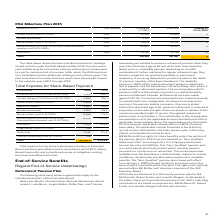According to Sap Ag's financial document, How was the Total expense for the share-based payment plans of Executive Board members determined? in accordance with IFRS 2 (Share- Based Payments) and consists exclusively of obligations arising from Executive Board activities.. The document states: "Board members was determined in accordance with IFRS 2 (Share- Based Payments) and consists exclusively of obligations arising from Executive Board ac..." Also, What is the total amount of expense for share-based payment in 2019? According to the financial document, 44,446.5 (in thousands). The relevant text states: "Total 44,446.5 8,054.4..." Also, In which years is the Total Expense for Share-Based Payment provided? The document shows two values: 2019 and 2018. From the document: "€ thousands 2019 2018 € thousands 2019 2018..." Also, How many Executive Board members had an expense for share-based payment of less than €1,000 thousand in 2019? Counting the relevant items in the document: Jürgen Müller, Thomas Saueressig, I find 2 instances. The key data points involved are: Jürgen Müller, Thomas Saueressig. Also, can you calculate: What was the change in the expense for share-based payment for  Stefan Ries  in 2019 from 2018? Based on the calculation:  2,646 - 772.0 , the result is 1874 (in thousands). This is based on the information: "Stefan Ries 2,646 772.0 Stefan Ries 2,646 772.0..." The key data points involved are: 2,646, 772.0. Also, can you calculate: What was the average total expense for share-based payment for  Stefan Ries  in 2018 and 2019? To answer this question, I need to perform calculations using the financial data. The calculation is:  (2,646 + 772.0)/2 , which equals 1709 (in thousands). This is based on the information: "Stefan Ries 2,646 772.0 Stefan Ries 2,646 772.0..." The key data points involved are: 2,646, 772.0. 